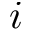Convert formula to latex. <formula><loc_0><loc_0><loc_500><loc_500>i</formula> 